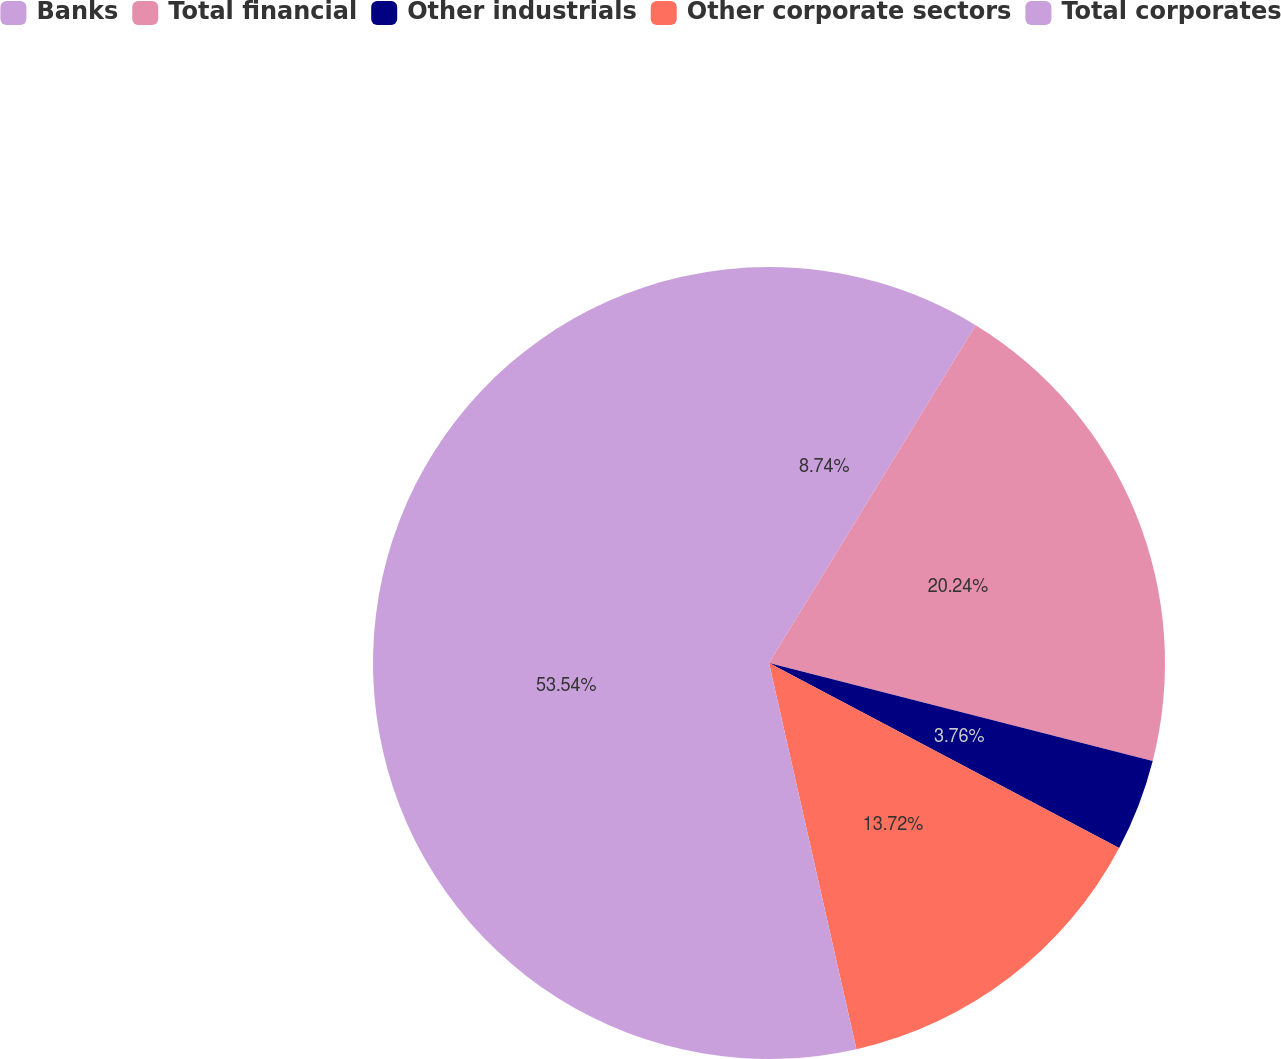Convert chart to OTSL. <chart><loc_0><loc_0><loc_500><loc_500><pie_chart><fcel>Banks<fcel>Total financial<fcel>Other industrials<fcel>Other corporate sectors<fcel>Total corporates<nl><fcel>8.74%<fcel>20.24%<fcel>3.76%<fcel>13.72%<fcel>53.55%<nl></chart> 